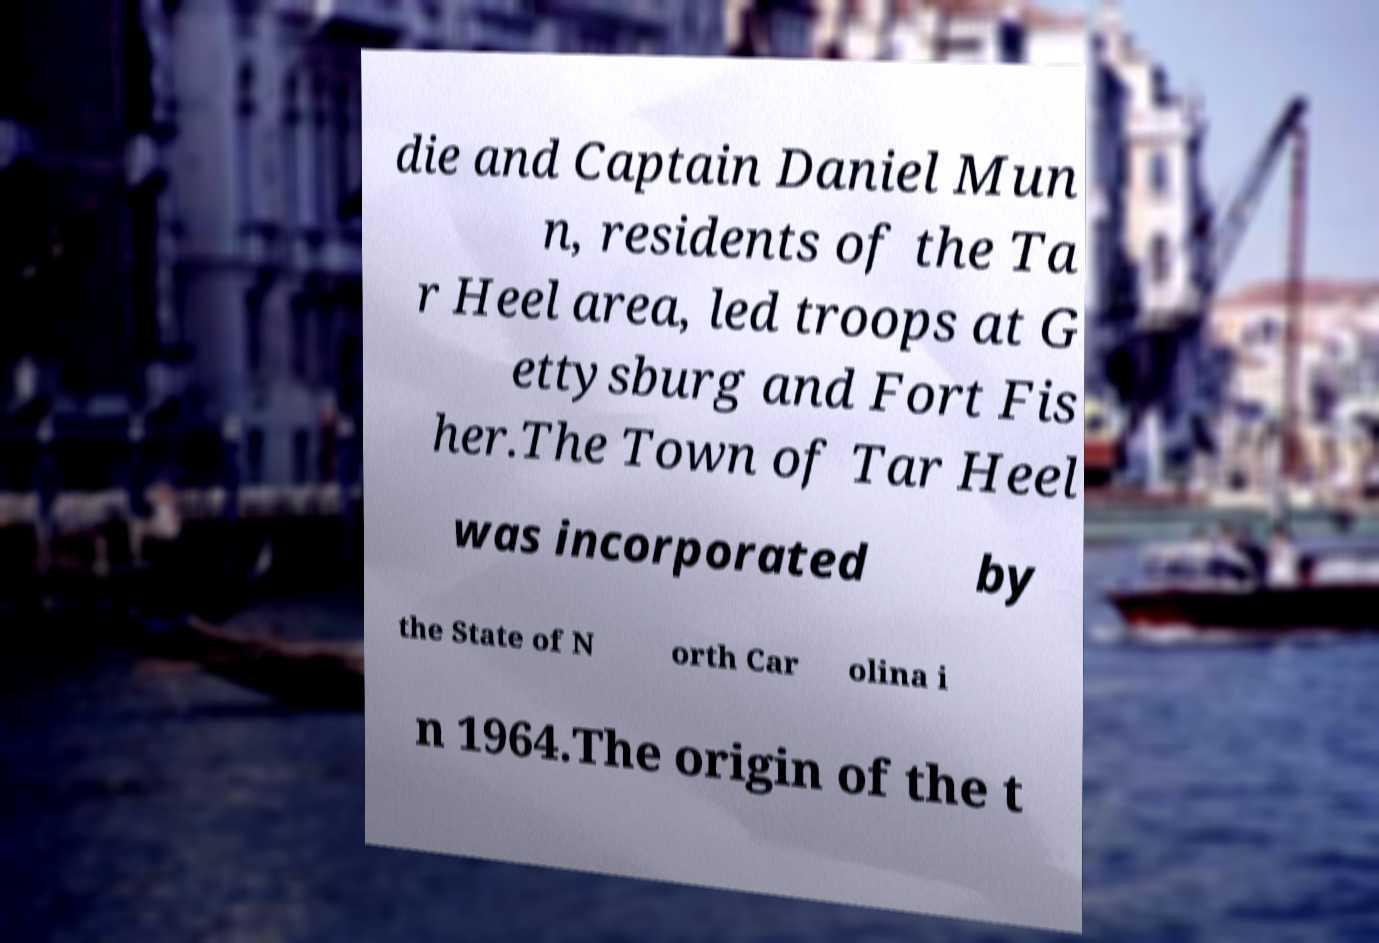There's text embedded in this image that I need extracted. Can you transcribe it verbatim? die and Captain Daniel Mun n, residents of the Ta r Heel area, led troops at G ettysburg and Fort Fis her.The Town of Tar Heel was incorporated by the State of N orth Car olina i n 1964.The origin of the t 